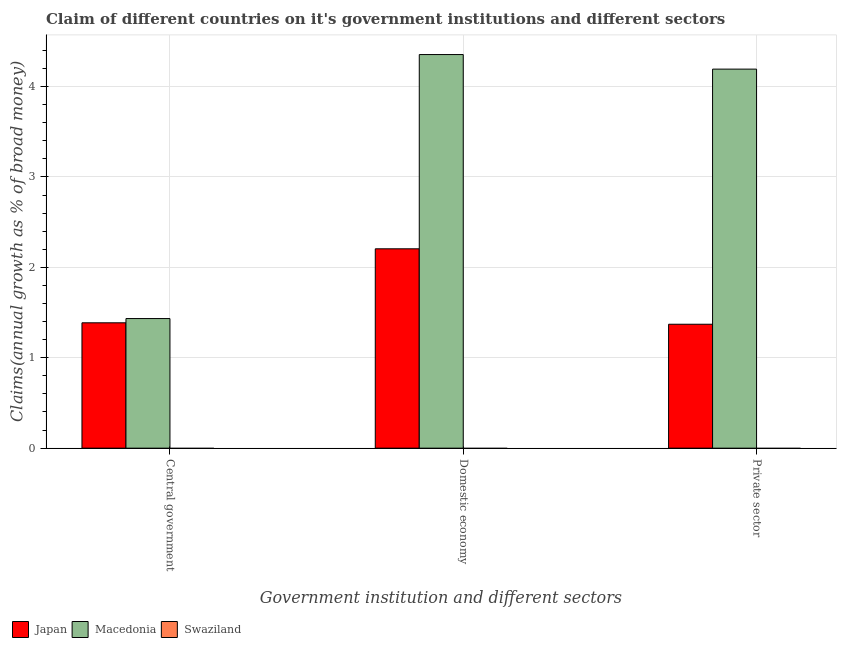How many different coloured bars are there?
Make the answer very short. 2. How many groups of bars are there?
Provide a succinct answer. 3. Are the number of bars per tick equal to the number of legend labels?
Your answer should be compact. No. Are the number of bars on each tick of the X-axis equal?
Offer a very short reply. Yes. How many bars are there on the 3rd tick from the left?
Provide a short and direct response. 2. How many bars are there on the 3rd tick from the right?
Give a very brief answer. 2. What is the label of the 3rd group of bars from the left?
Your answer should be very brief. Private sector. What is the percentage of claim on the central government in Macedonia?
Provide a short and direct response. 1.43. Across all countries, what is the maximum percentage of claim on the central government?
Provide a succinct answer. 1.43. Across all countries, what is the minimum percentage of claim on the central government?
Provide a short and direct response. 0. In which country was the percentage of claim on the private sector maximum?
Make the answer very short. Macedonia. What is the total percentage of claim on the central government in the graph?
Offer a terse response. 2.82. What is the difference between the percentage of claim on the central government in Japan and that in Macedonia?
Offer a very short reply. -0.05. What is the difference between the percentage of claim on the domestic economy in Swaziland and the percentage of claim on the private sector in Japan?
Offer a terse response. -1.37. What is the average percentage of claim on the private sector per country?
Your response must be concise. 1.85. What is the difference between the percentage of claim on the central government and percentage of claim on the domestic economy in Macedonia?
Your answer should be compact. -2.92. Is the difference between the percentage of claim on the private sector in Japan and Macedonia greater than the difference between the percentage of claim on the central government in Japan and Macedonia?
Your answer should be very brief. No. What is the difference between the highest and the lowest percentage of claim on the domestic economy?
Keep it short and to the point. 4.35. Is the sum of the percentage of claim on the central government in Japan and Macedonia greater than the maximum percentage of claim on the domestic economy across all countries?
Keep it short and to the point. No. Is it the case that in every country, the sum of the percentage of claim on the central government and percentage of claim on the domestic economy is greater than the percentage of claim on the private sector?
Ensure brevity in your answer.  No. How many bars are there?
Your answer should be compact. 6. What is the difference between two consecutive major ticks on the Y-axis?
Offer a very short reply. 1. Does the graph contain grids?
Your answer should be compact. Yes. What is the title of the graph?
Ensure brevity in your answer.  Claim of different countries on it's government institutions and different sectors. What is the label or title of the X-axis?
Keep it short and to the point. Government institution and different sectors. What is the label or title of the Y-axis?
Keep it short and to the point. Claims(annual growth as % of broad money). What is the Claims(annual growth as % of broad money) of Japan in Central government?
Give a very brief answer. 1.39. What is the Claims(annual growth as % of broad money) in Macedonia in Central government?
Your answer should be very brief. 1.43. What is the Claims(annual growth as % of broad money) in Japan in Domestic economy?
Make the answer very short. 2.21. What is the Claims(annual growth as % of broad money) in Macedonia in Domestic economy?
Your response must be concise. 4.35. What is the Claims(annual growth as % of broad money) in Japan in Private sector?
Provide a short and direct response. 1.37. What is the Claims(annual growth as % of broad money) of Macedonia in Private sector?
Offer a very short reply. 4.19. What is the Claims(annual growth as % of broad money) of Swaziland in Private sector?
Offer a very short reply. 0. Across all Government institution and different sectors, what is the maximum Claims(annual growth as % of broad money) of Japan?
Your response must be concise. 2.21. Across all Government institution and different sectors, what is the maximum Claims(annual growth as % of broad money) in Macedonia?
Offer a terse response. 4.35. Across all Government institution and different sectors, what is the minimum Claims(annual growth as % of broad money) in Japan?
Ensure brevity in your answer.  1.37. Across all Government institution and different sectors, what is the minimum Claims(annual growth as % of broad money) in Macedonia?
Keep it short and to the point. 1.43. What is the total Claims(annual growth as % of broad money) of Japan in the graph?
Your response must be concise. 4.96. What is the total Claims(annual growth as % of broad money) of Macedonia in the graph?
Make the answer very short. 9.98. What is the total Claims(annual growth as % of broad money) in Swaziland in the graph?
Your response must be concise. 0. What is the difference between the Claims(annual growth as % of broad money) in Japan in Central government and that in Domestic economy?
Make the answer very short. -0.82. What is the difference between the Claims(annual growth as % of broad money) of Macedonia in Central government and that in Domestic economy?
Keep it short and to the point. -2.92. What is the difference between the Claims(annual growth as % of broad money) of Japan in Central government and that in Private sector?
Make the answer very short. 0.02. What is the difference between the Claims(annual growth as % of broad money) in Macedonia in Central government and that in Private sector?
Make the answer very short. -2.76. What is the difference between the Claims(annual growth as % of broad money) in Japan in Domestic economy and that in Private sector?
Your response must be concise. 0.83. What is the difference between the Claims(annual growth as % of broad money) of Macedonia in Domestic economy and that in Private sector?
Give a very brief answer. 0.16. What is the difference between the Claims(annual growth as % of broad money) in Japan in Central government and the Claims(annual growth as % of broad money) in Macedonia in Domestic economy?
Provide a short and direct response. -2.97. What is the difference between the Claims(annual growth as % of broad money) in Japan in Central government and the Claims(annual growth as % of broad money) in Macedonia in Private sector?
Give a very brief answer. -2.81. What is the difference between the Claims(annual growth as % of broad money) of Japan in Domestic economy and the Claims(annual growth as % of broad money) of Macedonia in Private sector?
Give a very brief answer. -1.99. What is the average Claims(annual growth as % of broad money) in Japan per Government institution and different sectors?
Your response must be concise. 1.65. What is the average Claims(annual growth as % of broad money) of Macedonia per Government institution and different sectors?
Your response must be concise. 3.33. What is the difference between the Claims(annual growth as % of broad money) in Japan and Claims(annual growth as % of broad money) in Macedonia in Central government?
Offer a very short reply. -0.05. What is the difference between the Claims(annual growth as % of broad money) of Japan and Claims(annual growth as % of broad money) of Macedonia in Domestic economy?
Your answer should be compact. -2.15. What is the difference between the Claims(annual growth as % of broad money) in Japan and Claims(annual growth as % of broad money) in Macedonia in Private sector?
Make the answer very short. -2.82. What is the ratio of the Claims(annual growth as % of broad money) in Japan in Central government to that in Domestic economy?
Provide a succinct answer. 0.63. What is the ratio of the Claims(annual growth as % of broad money) in Macedonia in Central government to that in Domestic economy?
Give a very brief answer. 0.33. What is the ratio of the Claims(annual growth as % of broad money) in Japan in Central government to that in Private sector?
Ensure brevity in your answer.  1.01. What is the ratio of the Claims(annual growth as % of broad money) of Macedonia in Central government to that in Private sector?
Your answer should be very brief. 0.34. What is the ratio of the Claims(annual growth as % of broad money) of Japan in Domestic economy to that in Private sector?
Offer a terse response. 1.61. What is the ratio of the Claims(annual growth as % of broad money) of Macedonia in Domestic economy to that in Private sector?
Your answer should be compact. 1.04. What is the difference between the highest and the second highest Claims(annual growth as % of broad money) in Japan?
Offer a terse response. 0.82. What is the difference between the highest and the second highest Claims(annual growth as % of broad money) of Macedonia?
Provide a short and direct response. 0.16. What is the difference between the highest and the lowest Claims(annual growth as % of broad money) of Japan?
Offer a terse response. 0.83. What is the difference between the highest and the lowest Claims(annual growth as % of broad money) of Macedonia?
Provide a succinct answer. 2.92. 